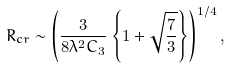<formula> <loc_0><loc_0><loc_500><loc_500>R _ { c r } \sim \left ( \frac { 3 } { 8 \lambda ^ { 2 } C _ { 3 } } \left \{ 1 + \sqrt { \frac { 7 } { 3 } } \right \} \right ) ^ { 1 / 4 } ,</formula> 